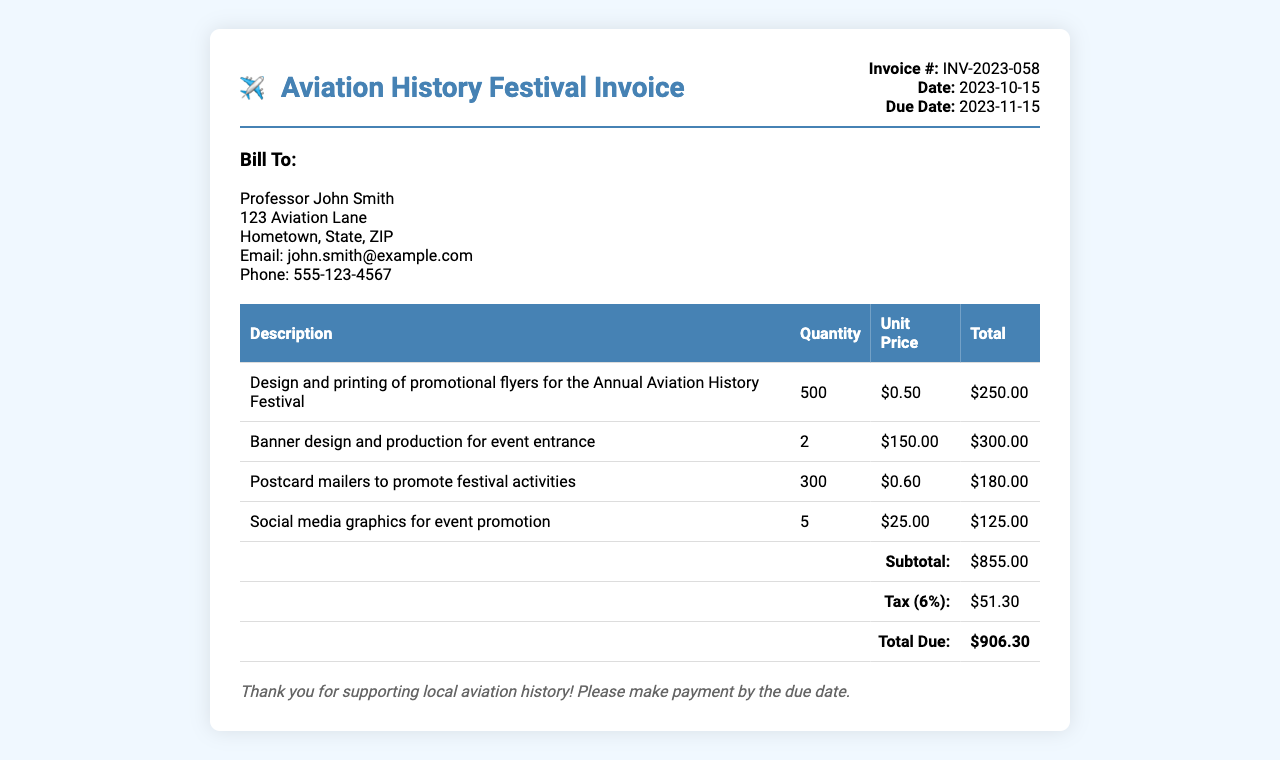What is the invoice number? The invoice number is located in the header section and identifies this specific invoice document.
Answer: INV-2023-058 Who is the invoice billed to? The billing information includes the name and address of the individual or entity responsible for payment.
Answer: Professor John Smith What is the due date for payment? The due date is specified in the invoice header, indicating when payment should be made.
Answer: 2023-11-15 How many flyers were printed? The quantity of promotional flyers is mentioned in the table under the description of the service provided.
Answer: 500 What is the subtotal amount before tax? The subtotal is calculated and displayed in the invoice just before the tax section.
Answer: $855.00 What is the total amount due after tax? The total amount due includes both the subtotal and the applicable tax, and is shown at the bottom of the invoice.
Answer: $906.30 What percentage is the tax applied to the subtotal? The tax rate is provided in the invoice and is based on the subtotal amount.
Answer: 6% What type of promotional materials are included? The invoice lists various items produced, which can be found in the description column of the table.
Answer: Flyers, Banners, Postcards, Graphics How many social media graphics were created? The specific quantity of the social media graphics is found in the product description section of the invoice.
Answer: 5 